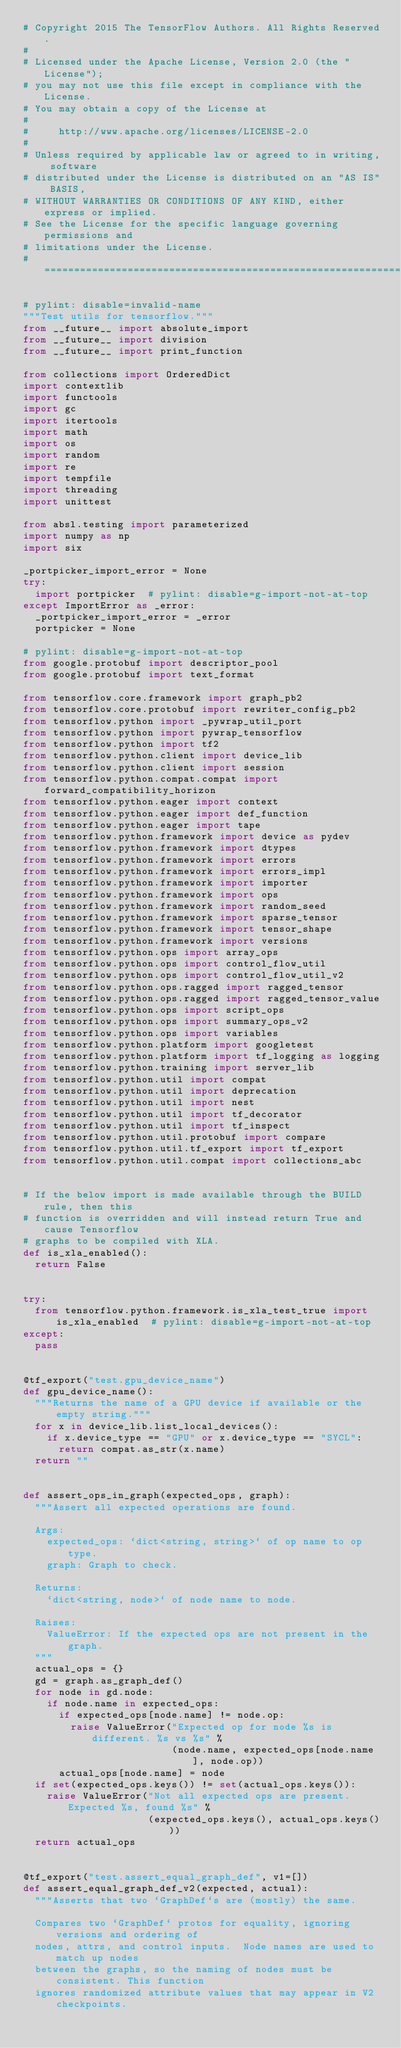Convert code to text. <code><loc_0><loc_0><loc_500><loc_500><_Python_># Copyright 2015 The TensorFlow Authors. All Rights Reserved.
#
# Licensed under the Apache License, Version 2.0 (the "License");
# you may not use this file except in compliance with the License.
# You may obtain a copy of the License at
#
#     http://www.apache.org/licenses/LICENSE-2.0
#
# Unless required by applicable law or agreed to in writing, software
# distributed under the License is distributed on an "AS IS" BASIS,
# WITHOUT WARRANTIES OR CONDITIONS OF ANY KIND, either express or implied.
# See the License for the specific language governing permissions and
# limitations under the License.
# ==============================================================================

# pylint: disable=invalid-name
"""Test utils for tensorflow."""
from __future__ import absolute_import
from __future__ import division
from __future__ import print_function

from collections import OrderedDict
import contextlib
import functools
import gc
import itertools
import math
import os
import random
import re
import tempfile
import threading
import unittest

from absl.testing import parameterized
import numpy as np
import six

_portpicker_import_error = None
try:
  import portpicker  # pylint: disable=g-import-not-at-top
except ImportError as _error:
  _portpicker_import_error = _error
  portpicker = None

# pylint: disable=g-import-not-at-top
from google.protobuf import descriptor_pool
from google.protobuf import text_format

from tensorflow.core.framework import graph_pb2
from tensorflow.core.protobuf import rewriter_config_pb2
from tensorflow.python import _pywrap_util_port
from tensorflow.python import pywrap_tensorflow
from tensorflow.python import tf2
from tensorflow.python.client import device_lib
from tensorflow.python.client import session
from tensorflow.python.compat.compat import forward_compatibility_horizon
from tensorflow.python.eager import context
from tensorflow.python.eager import def_function
from tensorflow.python.eager import tape
from tensorflow.python.framework import device as pydev
from tensorflow.python.framework import dtypes
from tensorflow.python.framework import errors
from tensorflow.python.framework import errors_impl
from tensorflow.python.framework import importer
from tensorflow.python.framework import ops
from tensorflow.python.framework import random_seed
from tensorflow.python.framework import sparse_tensor
from tensorflow.python.framework import tensor_shape
from tensorflow.python.framework import versions
from tensorflow.python.ops import array_ops
from tensorflow.python.ops import control_flow_util
from tensorflow.python.ops import control_flow_util_v2
from tensorflow.python.ops.ragged import ragged_tensor
from tensorflow.python.ops.ragged import ragged_tensor_value
from tensorflow.python.ops import script_ops
from tensorflow.python.ops import summary_ops_v2
from tensorflow.python.ops import variables
from tensorflow.python.platform import googletest
from tensorflow.python.platform import tf_logging as logging
from tensorflow.python.training import server_lib
from tensorflow.python.util import compat
from tensorflow.python.util import deprecation
from tensorflow.python.util import nest
from tensorflow.python.util import tf_decorator
from tensorflow.python.util import tf_inspect
from tensorflow.python.util.protobuf import compare
from tensorflow.python.util.tf_export import tf_export
from tensorflow.python.util.compat import collections_abc


# If the below import is made available through the BUILD rule, then this
# function is overridden and will instead return True and cause Tensorflow
# graphs to be compiled with XLA.
def is_xla_enabled():
  return False


try:
  from tensorflow.python.framework.is_xla_test_true import is_xla_enabled  # pylint: disable=g-import-not-at-top
except:
  pass


@tf_export("test.gpu_device_name")
def gpu_device_name():
  """Returns the name of a GPU device if available or the empty string."""
  for x in device_lib.list_local_devices():
    if x.device_type == "GPU" or x.device_type == "SYCL":
      return compat.as_str(x.name)
  return ""


def assert_ops_in_graph(expected_ops, graph):
  """Assert all expected operations are found.

  Args:
    expected_ops: `dict<string, string>` of op name to op type.
    graph: Graph to check.

  Returns:
    `dict<string, node>` of node name to node.

  Raises:
    ValueError: If the expected ops are not present in the graph.
  """
  actual_ops = {}
  gd = graph.as_graph_def()
  for node in gd.node:
    if node.name in expected_ops:
      if expected_ops[node.name] != node.op:
        raise ValueError("Expected op for node %s is different. %s vs %s" %
                         (node.name, expected_ops[node.name], node.op))
      actual_ops[node.name] = node
  if set(expected_ops.keys()) != set(actual_ops.keys()):
    raise ValueError("Not all expected ops are present. Expected %s, found %s" %
                     (expected_ops.keys(), actual_ops.keys()))
  return actual_ops


@tf_export("test.assert_equal_graph_def", v1=[])
def assert_equal_graph_def_v2(expected, actual):
  """Asserts that two `GraphDef`s are (mostly) the same.

  Compares two `GraphDef` protos for equality, ignoring versions and ordering of
  nodes, attrs, and control inputs.  Node names are used to match up nodes
  between the graphs, so the naming of nodes must be consistent. This function
  ignores randomized attribute values that may appear in V2 checkpoints.
</code> 